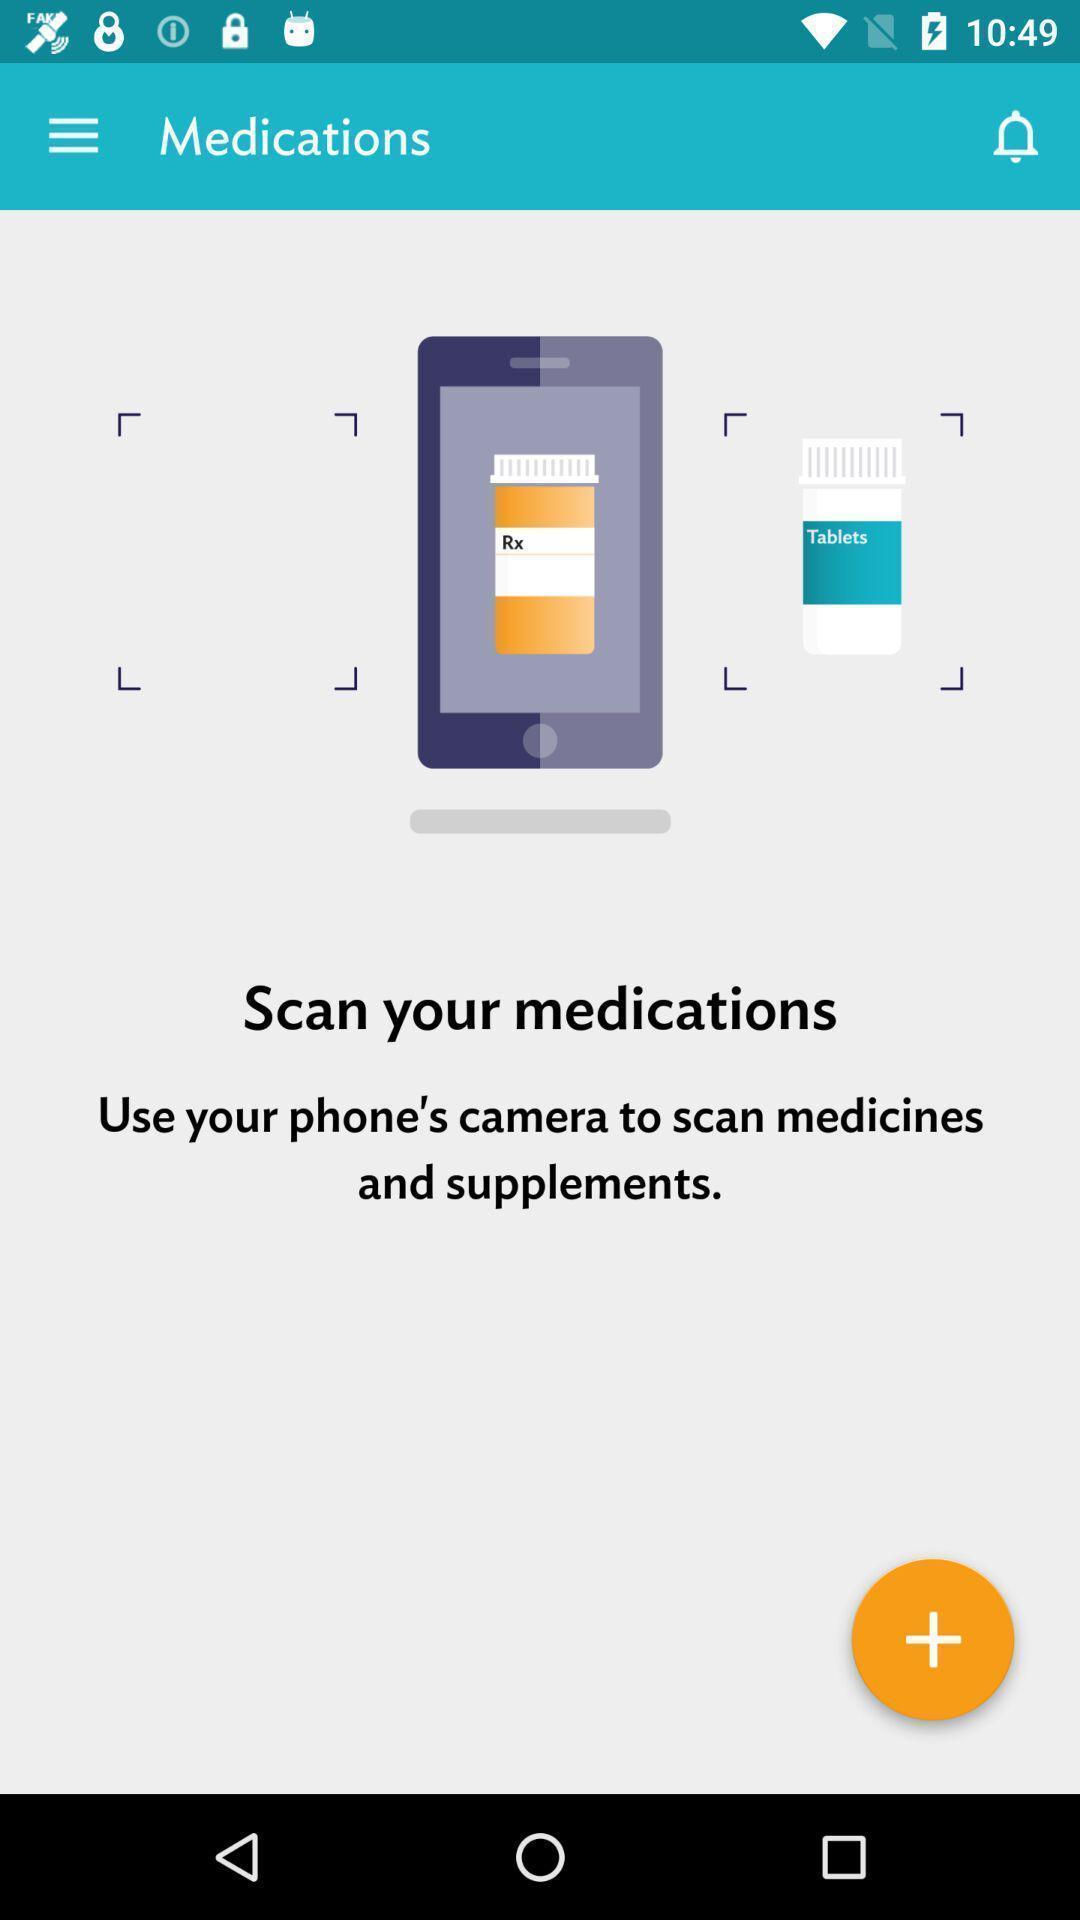Please provide a description for this image. Screen page displaying an information regarding scanning in health application. 